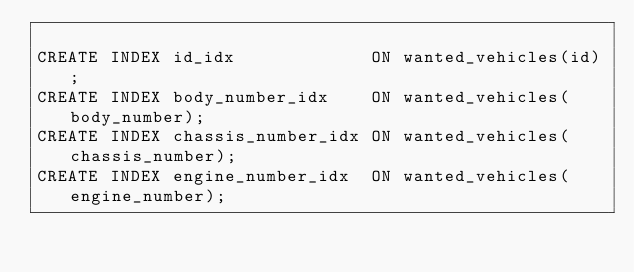<code> <loc_0><loc_0><loc_500><loc_500><_SQL_>
CREATE INDEX id_idx             ON wanted_vehicles(id);
CREATE INDEX body_number_idx    ON wanted_vehicles(body_number);
CREATE INDEX chassis_number_idx ON wanted_vehicles(chassis_number);
CREATE INDEX engine_number_idx  ON wanted_vehicles(engine_number);
</code> 